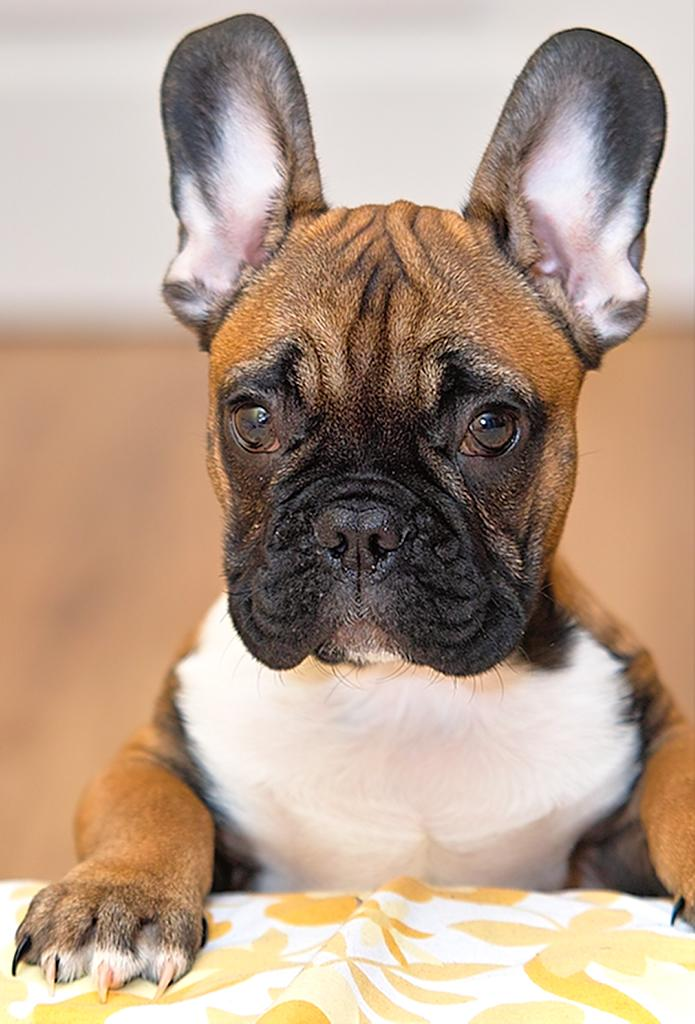What type of animal is in the image? There is a dog in the image. What is covering the dog in the image? There is a cloth in front of the dog. Can you describe the background of the image? The background appears blurry. What type of yarn is the dog using to play baseball in the image? There is no yarn or baseball present in the image; it only features a dog with a cloth in front of it. 